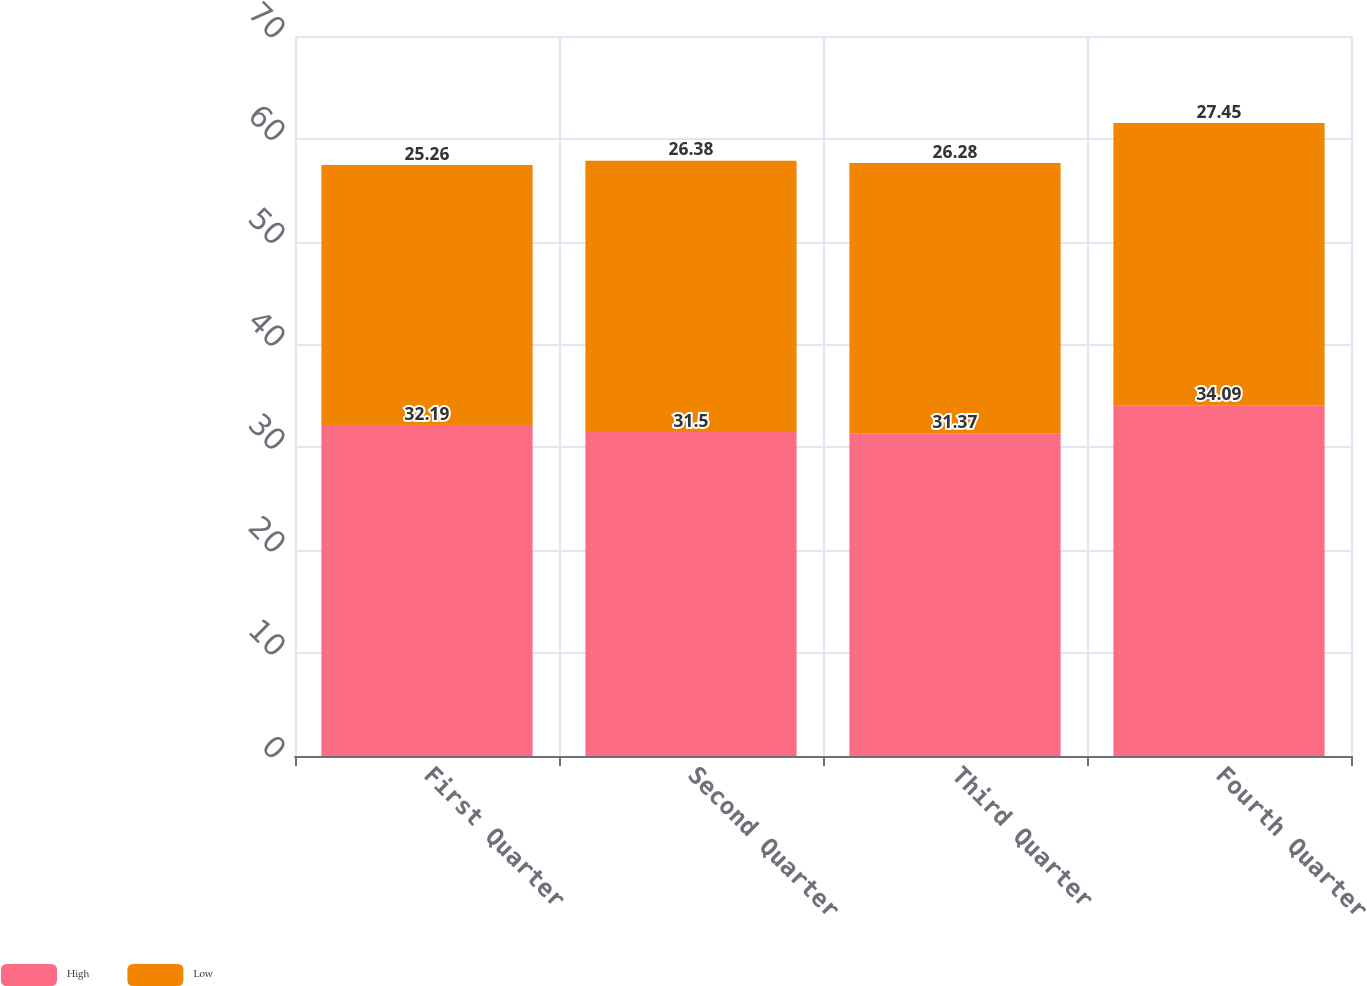Convert chart. <chart><loc_0><loc_0><loc_500><loc_500><stacked_bar_chart><ecel><fcel>First Quarter<fcel>Second Quarter<fcel>Third Quarter<fcel>Fourth Quarter<nl><fcel>High<fcel>32.19<fcel>31.5<fcel>31.37<fcel>34.09<nl><fcel>Low<fcel>25.26<fcel>26.38<fcel>26.28<fcel>27.45<nl></chart> 